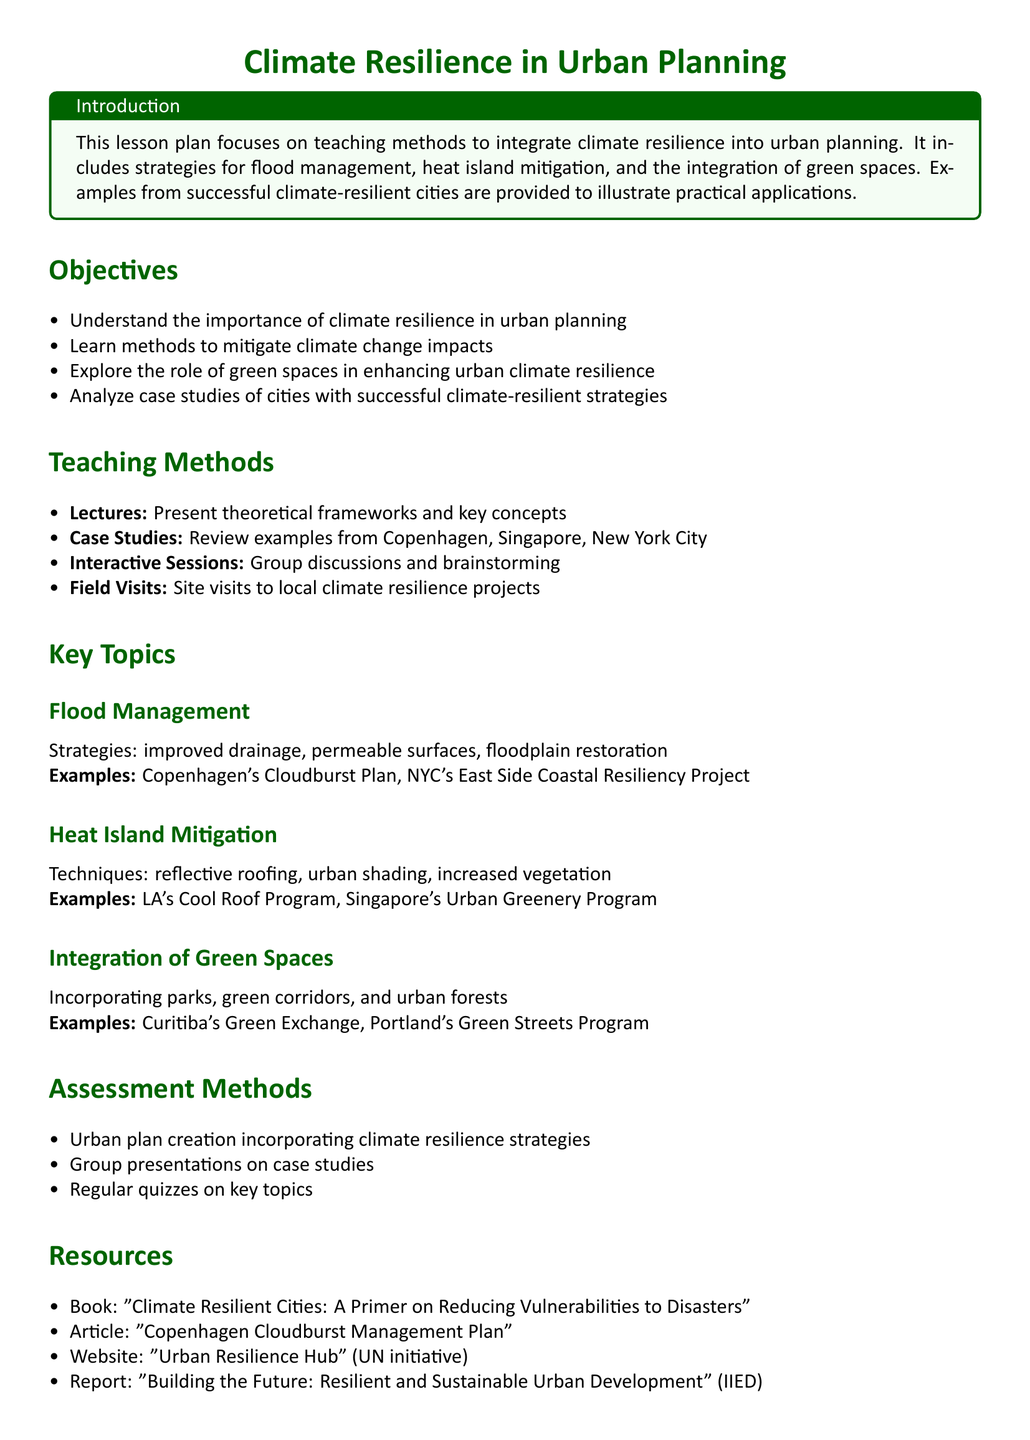What is the main focus of the lesson plan? The main focus of the lesson plan is to teach methods to integrate climate resilience into urban planning.
Answer: Integrate climate resilience What city is mentioned as part of the heat island mitigation examples? The lesson plan provides specific examples of cities implementing heat island mitigation strategies, one of which is Los Angeles.
Answer: Los Angeles What is one method listed for flood management? Strategies for flood management include improved drainage.
Answer: Improved drainage How many assessment methods are outlined in the lesson plan? The document lists three assessment methods for evaluating student understanding and application of the material.
Answer: Three Which program is cited as an example of integrating green spaces? The Curitiba's Green Exchange is an example of integrating green spaces mentioned in the document.
Answer: Curitiba's Green Exchange What type of sessions are included in the teaching methods? The teaching methods include interactive sessions for group discussions and brainstorming.
Answer: Interactive Sessions Name one resource cited in the lesson plan. One resource mentioned in the lesson plan is the book "Climate Resilient Cities: A Primer on Reducing Vulnerabilities to Disasters."
Answer: "Climate Resilient Cities: A Primer on Reducing Vulnerabilities to Disasters" What project is referenced for flood management in New York City? NYC's East Side Coastal Resiliency Project is referenced as an example for flood management.
Answer: NYC's East Side Coastal Resiliency Project What is the color used for the main title in the document? The title is styled in dark green color as defined in the document.
Answer: Dark green 